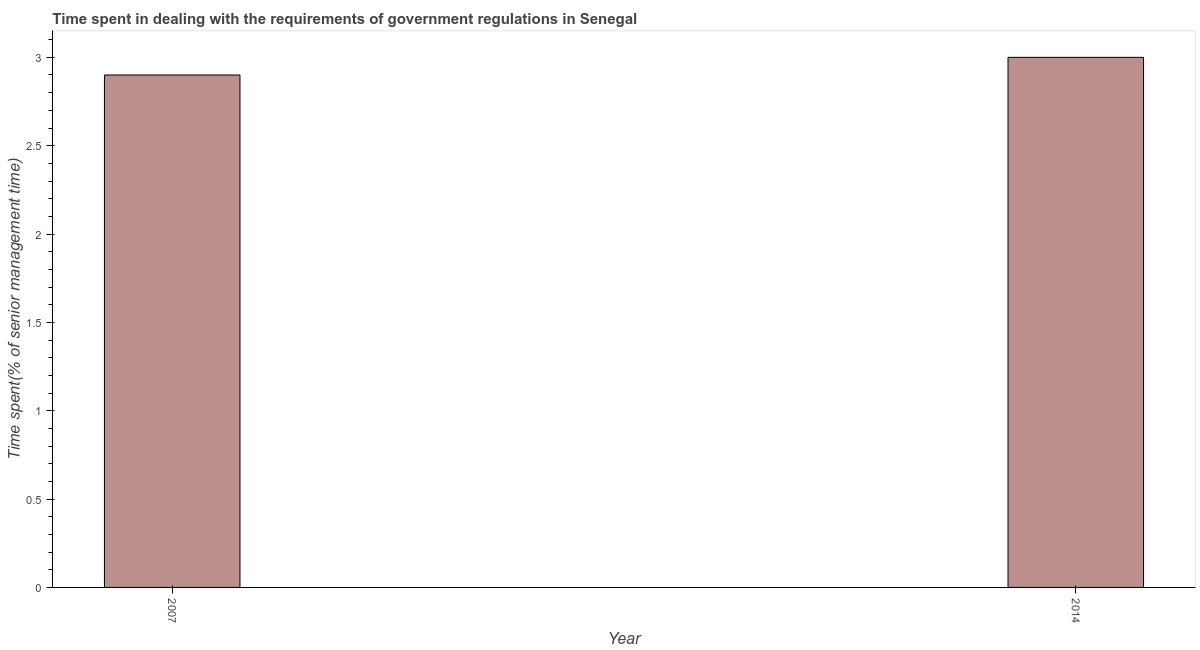Does the graph contain any zero values?
Your answer should be compact. No. What is the title of the graph?
Your answer should be very brief. Time spent in dealing with the requirements of government regulations in Senegal. What is the label or title of the Y-axis?
Give a very brief answer. Time spent(% of senior management time). Across all years, what is the maximum time spent in dealing with government regulations?
Offer a terse response. 3. In which year was the time spent in dealing with government regulations minimum?
Provide a short and direct response. 2007. What is the difference between the time spent in dealing with government regulations in 2007 and 2014?
Provide a succinct answer. -0.1. What is the average time spent in dealing with government regulations per year?
Offer a terse response. 2.95. What is the median time spent in dealing with government regulations?
Provide a short and direct response. 2.95. In how many years, is the time spent in dealing with government regulations greater than 2.8 %?
Your response must be concise. 2. What is the ratio of the time spent in dealing with government regulations in 2007 to that in 2014?
Offer a very short reply. 0.97. In how many years, is the time spent in dealing with government regulations greater than the average time spent in dealing with government regulations taken over all years?
Provide a short and direct response. 1. How many bars are there?
Offer a very short reply. 2. Are all the bars in the graph horizontal?
Offer a terse response. No. What is the difference between two consecutive major ticks on the Y-axis?
Ensure brevity in your answer.  0.5. What is the Time spent(% of senior management time) in 2014?
Provide a short and direct response. 3. What is the ratio of the Time spent(% of senior management time) in 2007 to that in 2014?
Ensure brevity in your answer.  0.97. 